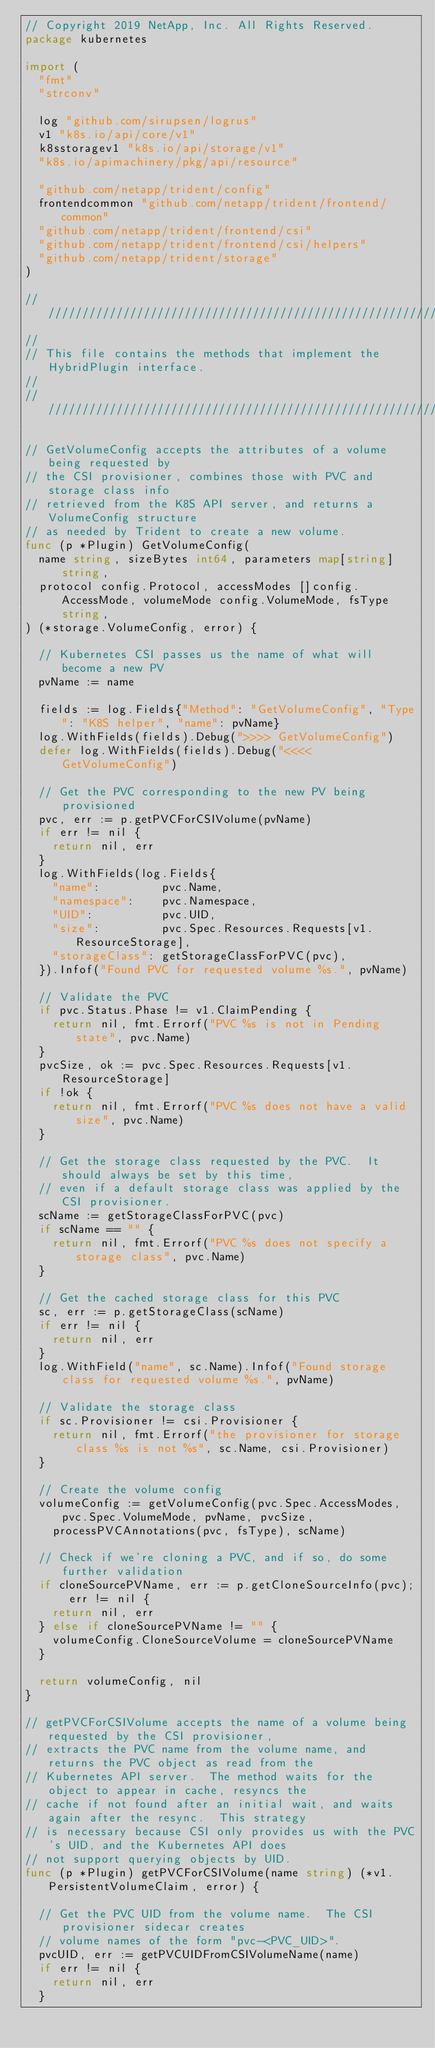Convert code to text. <code><loc_0><loc_0><loc_500><loc_500><_Go_>// Copyright 2019 NetApp, Inc. All Rights Reserved.
package kubernetes

import (
	"fmt"
	"strconv"

	log "github.com/sirupsen/logrus"
	v1 "k8s.io/api/core/v1"
	k8sstoragev1 "k8s.io/api/storage/v1"
	"k8s.io/apimachinery/pkg/api/resource"

	"github.com/netapp/trident/config"
	frontendcommon "github.com/netapp/trident/frontend/common"
	"github.com/netapp/trident/frontend/csi"
	"github.com/netapp/trident/frontend/csi/helpers"
	"github.com/netapp/trident/storage"
)

/////////////////////////////////////////////////////////////////////////////
//
// This file contains the methods that implement the HybridPlugin interface.
//
/////////////////////////////////////////////////////////////////////////////

// GetVolumeConfig accepts the attributes of a volume being requested by
// the CSI provisioner, combines those with PVC and storage class info
// retrieved from the K8S API server, and returns a VolumeConfig structure
// as needed by Trident to create a new volume.
func (p *Plugin) GetVolumeConfig(
	name string, sizeBytes int64, parameters map[string]string,
	protocol config.Protocol, accessModes []config.AccessMode, volumeMode config.VolumeMode, fsType string,
) (*storage.VolumeConfig, error) {

	// Kubernetes CSI passes us the name of what will become a new PV
	pvName := name

	fields := log.Fields{"Method": "GetVolumeConfig", "Type": "K8S helper", "name": pvName}
	log.WithFields(fields).Debug(">>>> GetVolumeConfig")
	defer log.WithFields(fields).Debug("<<<< GetVolumeConfig")

	// Get the PVC corresponding to the new PV being provisioned
	pvc, err := p.getPVCForCSIVolume(pvName)
	if err != nil {
		return nil, err
	}
	log.WithFields(log.Fields{
		"name":         pvc.Name,
		"namespace":    pvc.Namespace,
		"UID":          pvc.UID,
		"size":         pvc.Spec.Resources.Requests[v1.ResourceStorage],
		"storageClass": getStorageClassForPVC(pvc),
	}).Infof("Found PVC for requested volume %s.", pvName)

	// Validate the PVC
	if pvc.Status.Phase != v1.ClaimPending {
		return nil, fmt.Errorf("PVC %s is not in Pending state", pvc.Name)
	}
	pvcSize, ok := pvc.Spec.Resources.Requests[v1.ResourceStorage]
	if !ok {
		return nil, fmt.Errorf("PVC %s does not have a valid size", pvc.Name)
	}

	// Get the storage class requested by the PVC.  It should always be set by this time,
	// even if a default storage class was applied by the CSI provisioner.
	scName := getStorageClassForPVC(pvc)
	if scName == "" {
		return nil, fmt.Errorf("PVC %s does not specify a storage class", pvc.Name)
	}

	// Get the cached storage class for this PVC
	sc, err := p.getStorageClass(scName)
	if err != nil {
		return nil, err
	}
	log.WithField("name", sc.Name).Infof("Found storage class for requested volume %s.", pvName)

	// Validate the storage class
	if sc.Provisioner != csi.Provisioner {
		return nil, fmt.Errorf("the provisioner for storage class %s is not %s", sc.Name, csi.Provisioner)
	}

	// Create the volume config
	volumeConfig := getVolumeConfig(pvc.Spec.AccessModes, pvc.Spec.VolumeMode, pvName, pvcSize,
		processPVCAnnotations(pvc, fsType), scName)

	// Check if we're cloning a PVC, and if so, do some further validation
	if cloneSourcePVName, err := p.getCloneSourceInfo(pvc); err != nil {
		return nil, err
	} else if cloneSourcePVName != "" {
		volumeConfig.CloneSourceVolume = cloneSourcePVName
	}

	return volumeConfig, nil
}

// getPVCForCSIVolume accepts the name of a volume being requested by the CSI provisioner,
// extracts the PVC name from the volume name, and returns the PVC object as read from the
// Kubernetes API server.  The method waits for the object to appear in cache, resyncs the
// cache if not found after an initial wait, and waits again after the resync.  This strategy
// is necessary because CSI only provides us with the PVC's UID, and the Kubernetes API does
// not support querying objects by UID.
func (p *Plugin) getPVCForCSIVolume(name string) (*v1.PersistentVolumeClaim, error) {

	// Get the PVC UID from the volume name.  The CSI provisioner sidecar creates
	// volume names of the form "pvc-<PVC_UID>".
	pvcUID, err := getPVCUIDFromCSIVolumeName(name)
	if err != nil {
		return nil, err
	}
</code> 